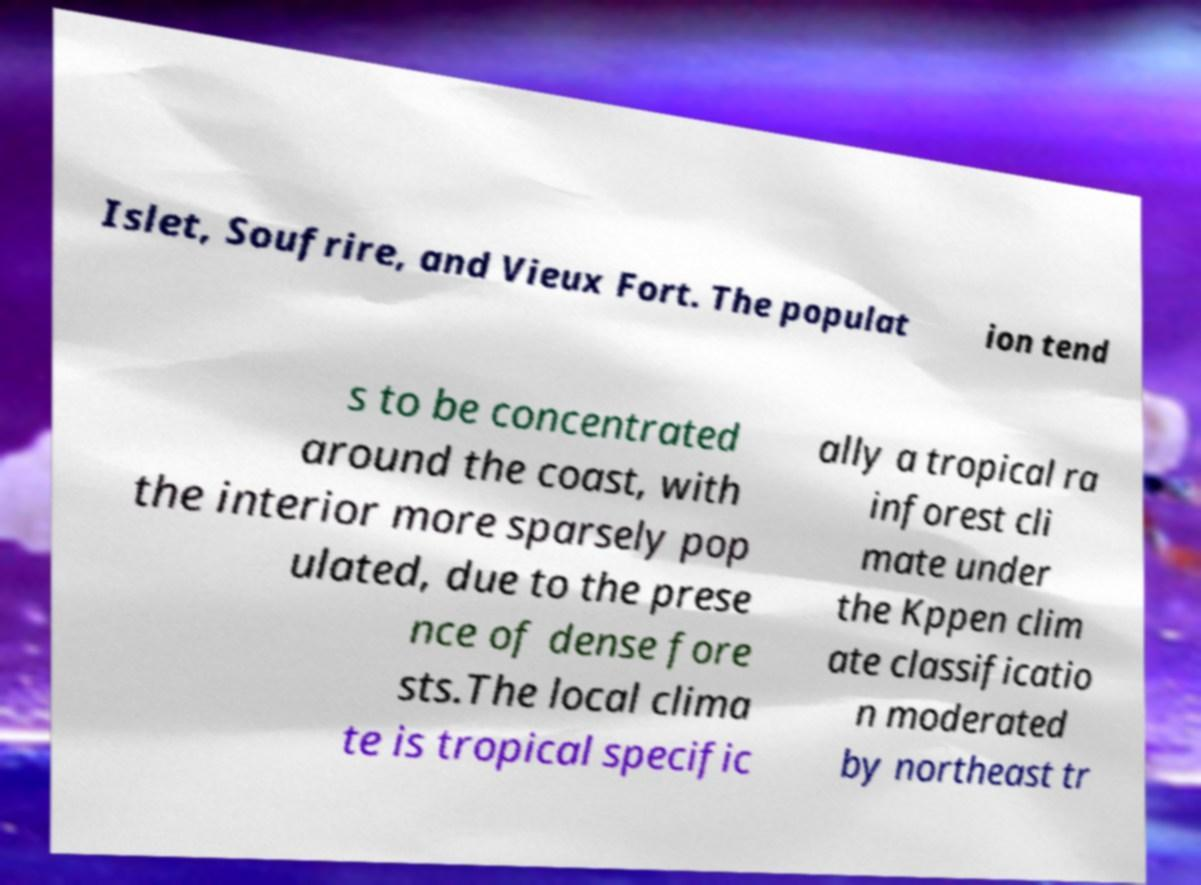Could you assist in decoding the text presented in this image and type it out clearly? Islet, Soufrire, and Vieux Fort. The populat ion tend s to be concentrated around the coast, with the interior more sparsely pop ulated, due to the prese nce of dense fore sts.The local clima te is tropical specific ally a tropical ra inforest cli mate under the Kppen clim ate classificatio n moderated by northeast tr 